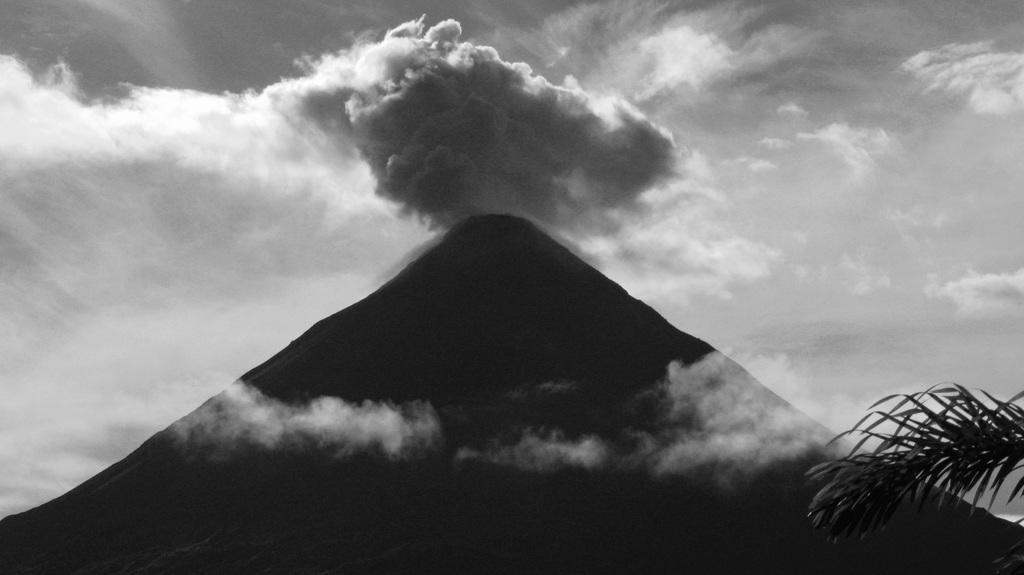Could you give a brief overview of what you see in this image? Here in this picture we can see a mountain present and we can see the sky is fully covered with clouds and on the right side we can see a branch of a tree present. 